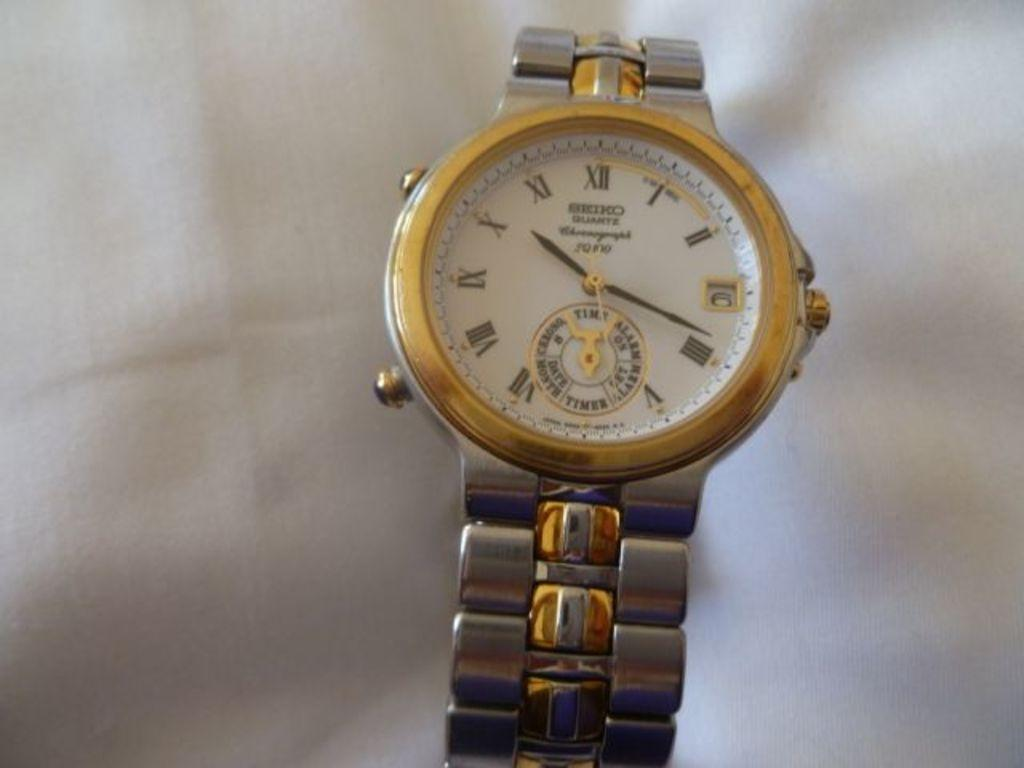What object is visible in the image? There is a wrist watch in the image. Where is the wrist watch located? The wrist watch is placed on a surface. How much profit does the paste make in the image? There is no mention of paste or profit in the image, as it only features a wrist watch placed on a surface. 